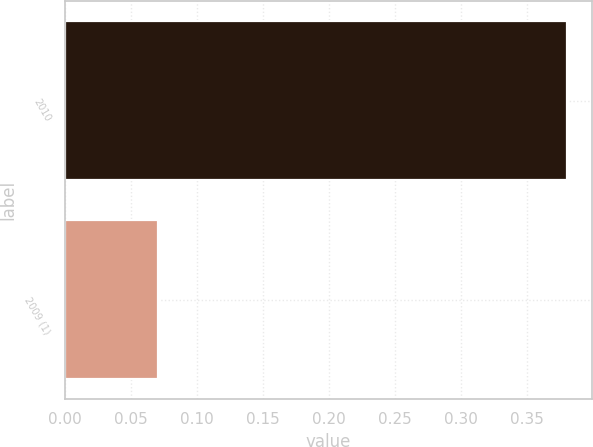Convert chart. <chart><loc_0><loc_0><loc_500><loc_500><bar_chart><fcel>2010<fcel>2009 (1)<nl><fcel>0.38<fcel>0.07<nl></chart> 